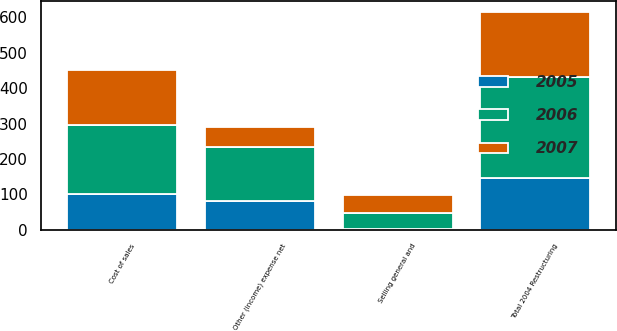Convert chart. <chart><loc_0><loc_0><loc_500><loc_500><stacked_bar_chart><ecel><fcel>Cost of sales<fcel>Selling general and<fcel>Other (income) expense net<fcel>Total 2004 Restructuring<nl><fcel>2007<fcel>153.8<fcel>49.1<fcel>55.6<fcel>183.7<nl><fcel>2006<fcel>196.2<fcel>46.1<fcel>153.1<fcel>286.3<nl><fcel>2005<fcel>100.2<fcel>1.8<fcel>80.8<fcel>145.1<nl></chart> 